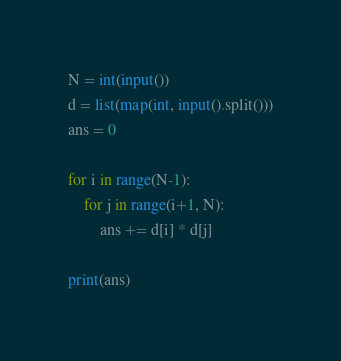Convert code to text. <code><loc_0><loc_0><loc_500><loc_500><_Python_>N = int(input())
d = list(map(int, input().split()))
ans = 0

for i in range(N-1):
    for j in range(i+1, N):
        ans += d[i] * d[j]

print(ans)</code> 